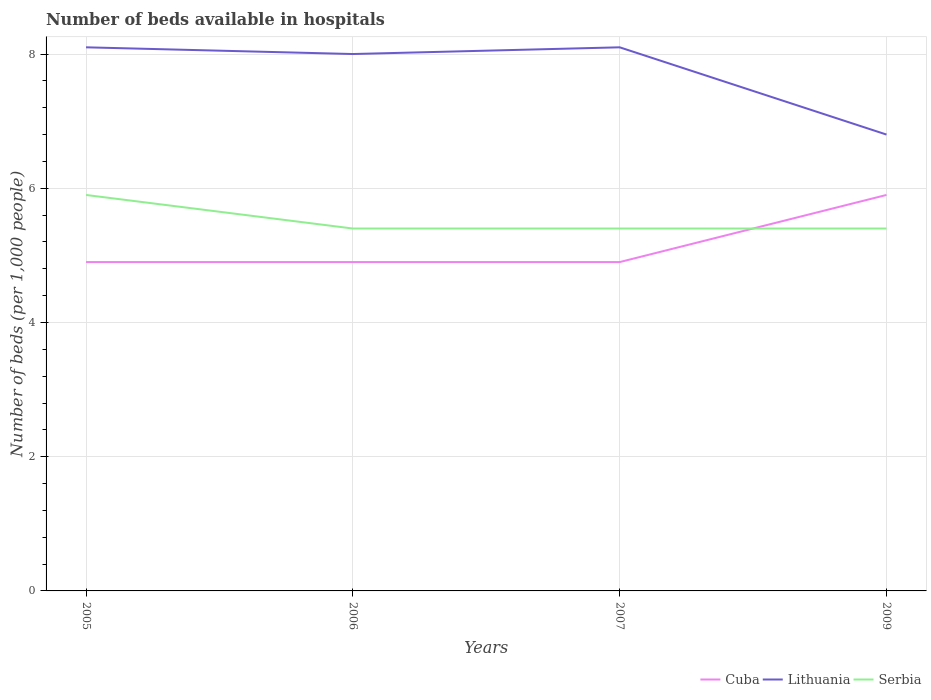Does the line corresponding to Cuba intersect with the line corresponding to Serbia?
Give a very brief answer. Yes. Is the number of lines equal to the number of legend labels?
Offer a terse response. Yes. In which year was the number of beds in the hospiatls of in Lithuania maximum?
Your answer should be very brief. 2009. What is the total number of beds in the hospiatls of in Serbia in the graph?
Ensure brevity in your answer.  0.5. What is the difference between the highest and the second highest number of beds in the hospiatls of in Cuba?
Your response must be concise. 1. What is the difference between the highest and the lowest number of beds in the hospiatls of in Cuba?
Your answer should be compact. 1. What is the difference between two consecutive major ticks on the Y-axis?
Keep it short and to the point. 2. Does the graph contain grids?
Provide a succinct answer. Yes. Where does the legend appear in the graph?
Offer a terse response. Bottom right. How are the legend labels stacked?
Keep it short and to the point. Horizontal. What is the title of the graph?
Your response must be concise. Number of beds available in hospitals. Does "Heavily indebted poor countries" appear as one of the legend labels in the graph?
Offer a terse response. No. What is the label or title of the X-axis?
Give a very brief answer. Years. What is the label or title of the Y-axis?
Provide a succinct answer. Number of beds (per 1,0 people). What is the Number of beds (per 1,000 people) of Cuba in 2005?
Keep it short and to the point. 4.9. What is the Number of beds (per 1,000 people) in Serbia in 2005?
Your answer should be compact. 5.9. What is the Number of beds (per 1,000 people) in Cuba in 2006?
Ensure brevity in your answer.  4.9. What is the Number of beds (per 1,000 people) in Lithuania in 2006?
Ensure brevity in your answer.  8. What is the Number of beds (per 1,000 people) in Lithuania in 2007?
Ensure brevity in your answer.  8.1. What is the Number of beds (per 1,000 people) in Cuba in 2009?
Your response must be concise. 5.9. What is the Number of beds (per 1,000 people) of Lithuania in 2009?
Make the answer very short. 6.8. Across all years, what is the maximum Number of beds (per 1,000 people) of Lithuania?
Your answer should be very brief. 8.1. Across all years, what is the minimum Number of beds (per 1,000 people) in Serbia?
Offer a very short reply. 5.4. What is the total Number of beds (per 1,000 people) of Cuba in the graph?
Ensure brevity in your answer.  20.6. What is the total Number of beds (per 1,000 people) in Lithuania in the graph?
Offer a very short reply. 31. What is the total Number of beds (per 1,000 people) of Serbia in the graph?
Offer a terse response. 22.1. What is the difference between the Number of beds (per 1,000 people) in Cuba in 2005 and that in 2006?
Make the answer very short. 0. What is the difference between the Number of beds (per 1,000 people) in Lithuania in 2005 and that in 2006?
Your response must be concise. 0.1. What is the difference between the Number of beds (per 1,000 people) in Serbia in 2005 and that in 2006?
Give a very brief answer. 0.5. What is the difference between the Number of beds (per 1,000 people) in Cuba in 2005 and that in 2007?
Make the answer very short. 0. What is the difference between the Number of beds (per 1,000 people) of Serbia in 2005 and that in 2009?
Give a very brief answer. 0.5. What is the difference between the Number of beds (per 1,000 people) of Lithuania in 2006 and that in 2007?
Make the answer very short. -0.1. What is the difference between the Number of beds (per 1,000 people) in Cuba in 2006 and that in 2009?
Your answer should be very brief. -1. What is the difference between the Number of beds (per 1,000 people) of Serbia in 2007 and that in 2009?
Your answer should be very brief. 0. What is the difference between the Number of beds (per 1,000 people) in Cuba in 2005 and the Number of beds (per 1,000 people) in Serbia in 2006?
Offer a very short reply. -0.5. What is the difference between the Number of beds (per 1,000 people) in Lithuania in 2005 and the Number of beds (per 1,000 people) in Serbia in 2006?
Your answer should be very brief. 2.7. What is the difference between the Number of beds (per 1,000 people) of Cuba in 2005 and the Number of beds (per 1,000 people) of Serbia in 2007?
Your answer should be very brief. -0.5. What is the difference between the Number of beds (per 1,000 people) in Cuba in 2005 and the Number of beds (per 1,000 people) in Serbia in 2009?
Keep it short and to the point. -0.5. What is the difference between the Number of beds (per 1,000 people) in Lithuania in 2005 and the Number of beds (per 1,000 people) in Serbia in 2009?
Make the answer very short. 2.7. What is the difference between the Number of beds (per 1,000 people) in Cuba in 2006 and the Number of beds (per 1,000 people) in Lithuania in 2007?
Your answer should be very brief. -3.2. What is the difference between the Number of beds (per 1,000 people) of Cuba in 2006 and the Number of beds (per 1,000 people) of Serbia in 2007?
Make the answer very short. -0.5. What is the difference between the Number of beds (per 1,000 people) of Cuba in 2006 and the Number of beds (per 1,000 people) of Lithuania in 2009?
Your response must be concise. -1.9. What is the difference between the Number of beds (per 1,000 people) of Lithuania in 2007 and the Number of beds (per 1,000 people) of Serbia in 2009?
Your answer should be very brief. 2.7. What is the average Number of beds (per 1,000 people) in Cuba per year?
Ensure brevity in your answer.  5.15. What is the average Number of beds (per 1,000 people) of Lithuania per year?
Ensure brevity in your answer.  7.75. What is the average Number of beds (per 1,000 people) of Serbia per year?
Your answer should be very brief. 5.53. In the year 2005, what is the difference between the Number of beds (per 1,000 people) in Cuba and Number of beds (per 1,000 people) in Lithuania?
Provide a short and direct response. -3.2. In the year 2006, what is the difference between the Number of beds (per 1,000 people) of Cuba and Number of beds (per 1,000 people) of Serbia?
Give a very brief answer. -0.5. In the year 2006, what is the difference between the Number of beds (per 1,000 people) of Lithuania and Number of beds (per 1,000 people) of Serbia?
Ensure brevity in your answer.  2.6. In the year 2007, what is the difference between the Number of beds (per 1,000 people) in Cuba and Number of beds (per 1,000 people) in Lithuania?
Give a very brief answer. -3.2. In the year 2007, what is the difference between the Number of beds (per 1,000 people) in Cuba and Number of beds (per 1,000 people) in Serbia?
Provide a short and direct response. -0.5. In the year 2007, what is the difference between the Number of beds (per 1,000 people) in Lithuania and Number of beds (per 1,000 people) in Serbia?
Make the answer very short. 2.7. In the year 2009, what is the difference between the Number of beds (per 1,000 people) in Cuba and Number of beds (per 1,000 people) in Serbia?
Offer a terse response. 0.5. What is the ratio of the Number of beds (per 1,000 people) of Lithuania in 2005 to that in 2006?
Offer a terse response. 1.01. What is the ratio of the Number of beds (per 1,000 people) in Serbia in 2005 to that in 2006?
Provide a short and direct response. 1.09. What is the ratio of the Number of beds (per 1,000 people) in Serbia in 2005 to that in 2007?
Your response must be concise. 1.09. What is the ratio of the Number of beds (per 1,000 people) in Cuba in 2005 to that in 2009?
Your answer should be compact. 0.83. What is the ratio of the Number of beds (per 1,000 people) in Lithuania in 2005 to that in 2009?
Your response must be concise. 1.19. What is the ratio of the Number of beds (per 1,000 people) in Serbia in 2005 to that in 2009?
Keep it short and to the point. 1.09. What is the ratio of the Number of beds (per 1,000 people) in Lithuania in 2006 to that in 2007?
Ensure brevity in your answer.  0.99. What is the ratio of the Number of beds (per 1,000 people) of Serbia in 2006 to that in 2007?
Keep it short and to the point. 1. What is the ratio of the Number of beds (per 1,000 people) in Cuba in 2006 to that in 2009?
Offer a terse response. 0.83. What is the ratio of the Number of beds (per 1,000 people) in Lithuania in 2006 to that in 2009?
Provide a succinct answer. 1.18. What is the ratio of the Number of beds (per 1,000 people) in Serbia in 2006 to that in 2009?
Your response must be concise. 1. What is the ratio of the Number of beds (per 1,000 people) in Cuba in 2007 to that in 2009?
Give a very brief answer. 0.83. What is the ratio of the Number of beds (per 1,000 people) of Lithuania in 2007 to that in 2009?
Make the answer very short. 1.19. What is the ratio of the Number of beds (per 1,000 people) in Serbia in 2007 to that in 2009?
Your answer should be very brief. 1. What is the difference between the highest and the second highest Number of beds (per 1,000 people) in Cuba?
Ensure brevity in your answer.  1. What is the difference between the highest and the second highest Number of beds (per 1,000 people) of Serbia?
Your response must be concise. 0.5. What is the difference between the highest and the lowest Number of beds (per 1,000 people) of Cuba?
Provide a short and direct response. 1. What is the difference between the highest and the lowest Number of beds (per 1,000 people) of Lithuania?
Make the answer very short. 1.3. 